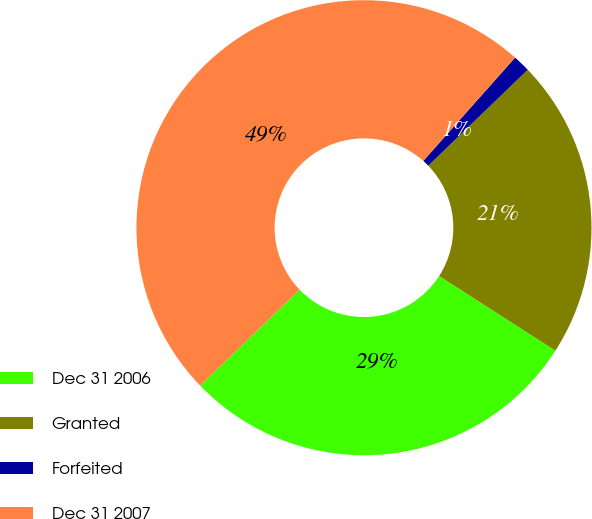Convert chart to OTSL. <chart><loc_0><loc_0><loc_500><loc_500><pie_chart><fcel>Dec 31 2006<fcel>Granted<fcel>Forfeited<fcel>Dec 31 2007<nl><fcel>28.7%<fcel>21.3%<fcel>1.23%<fcel>48.77%<nl></chart> 